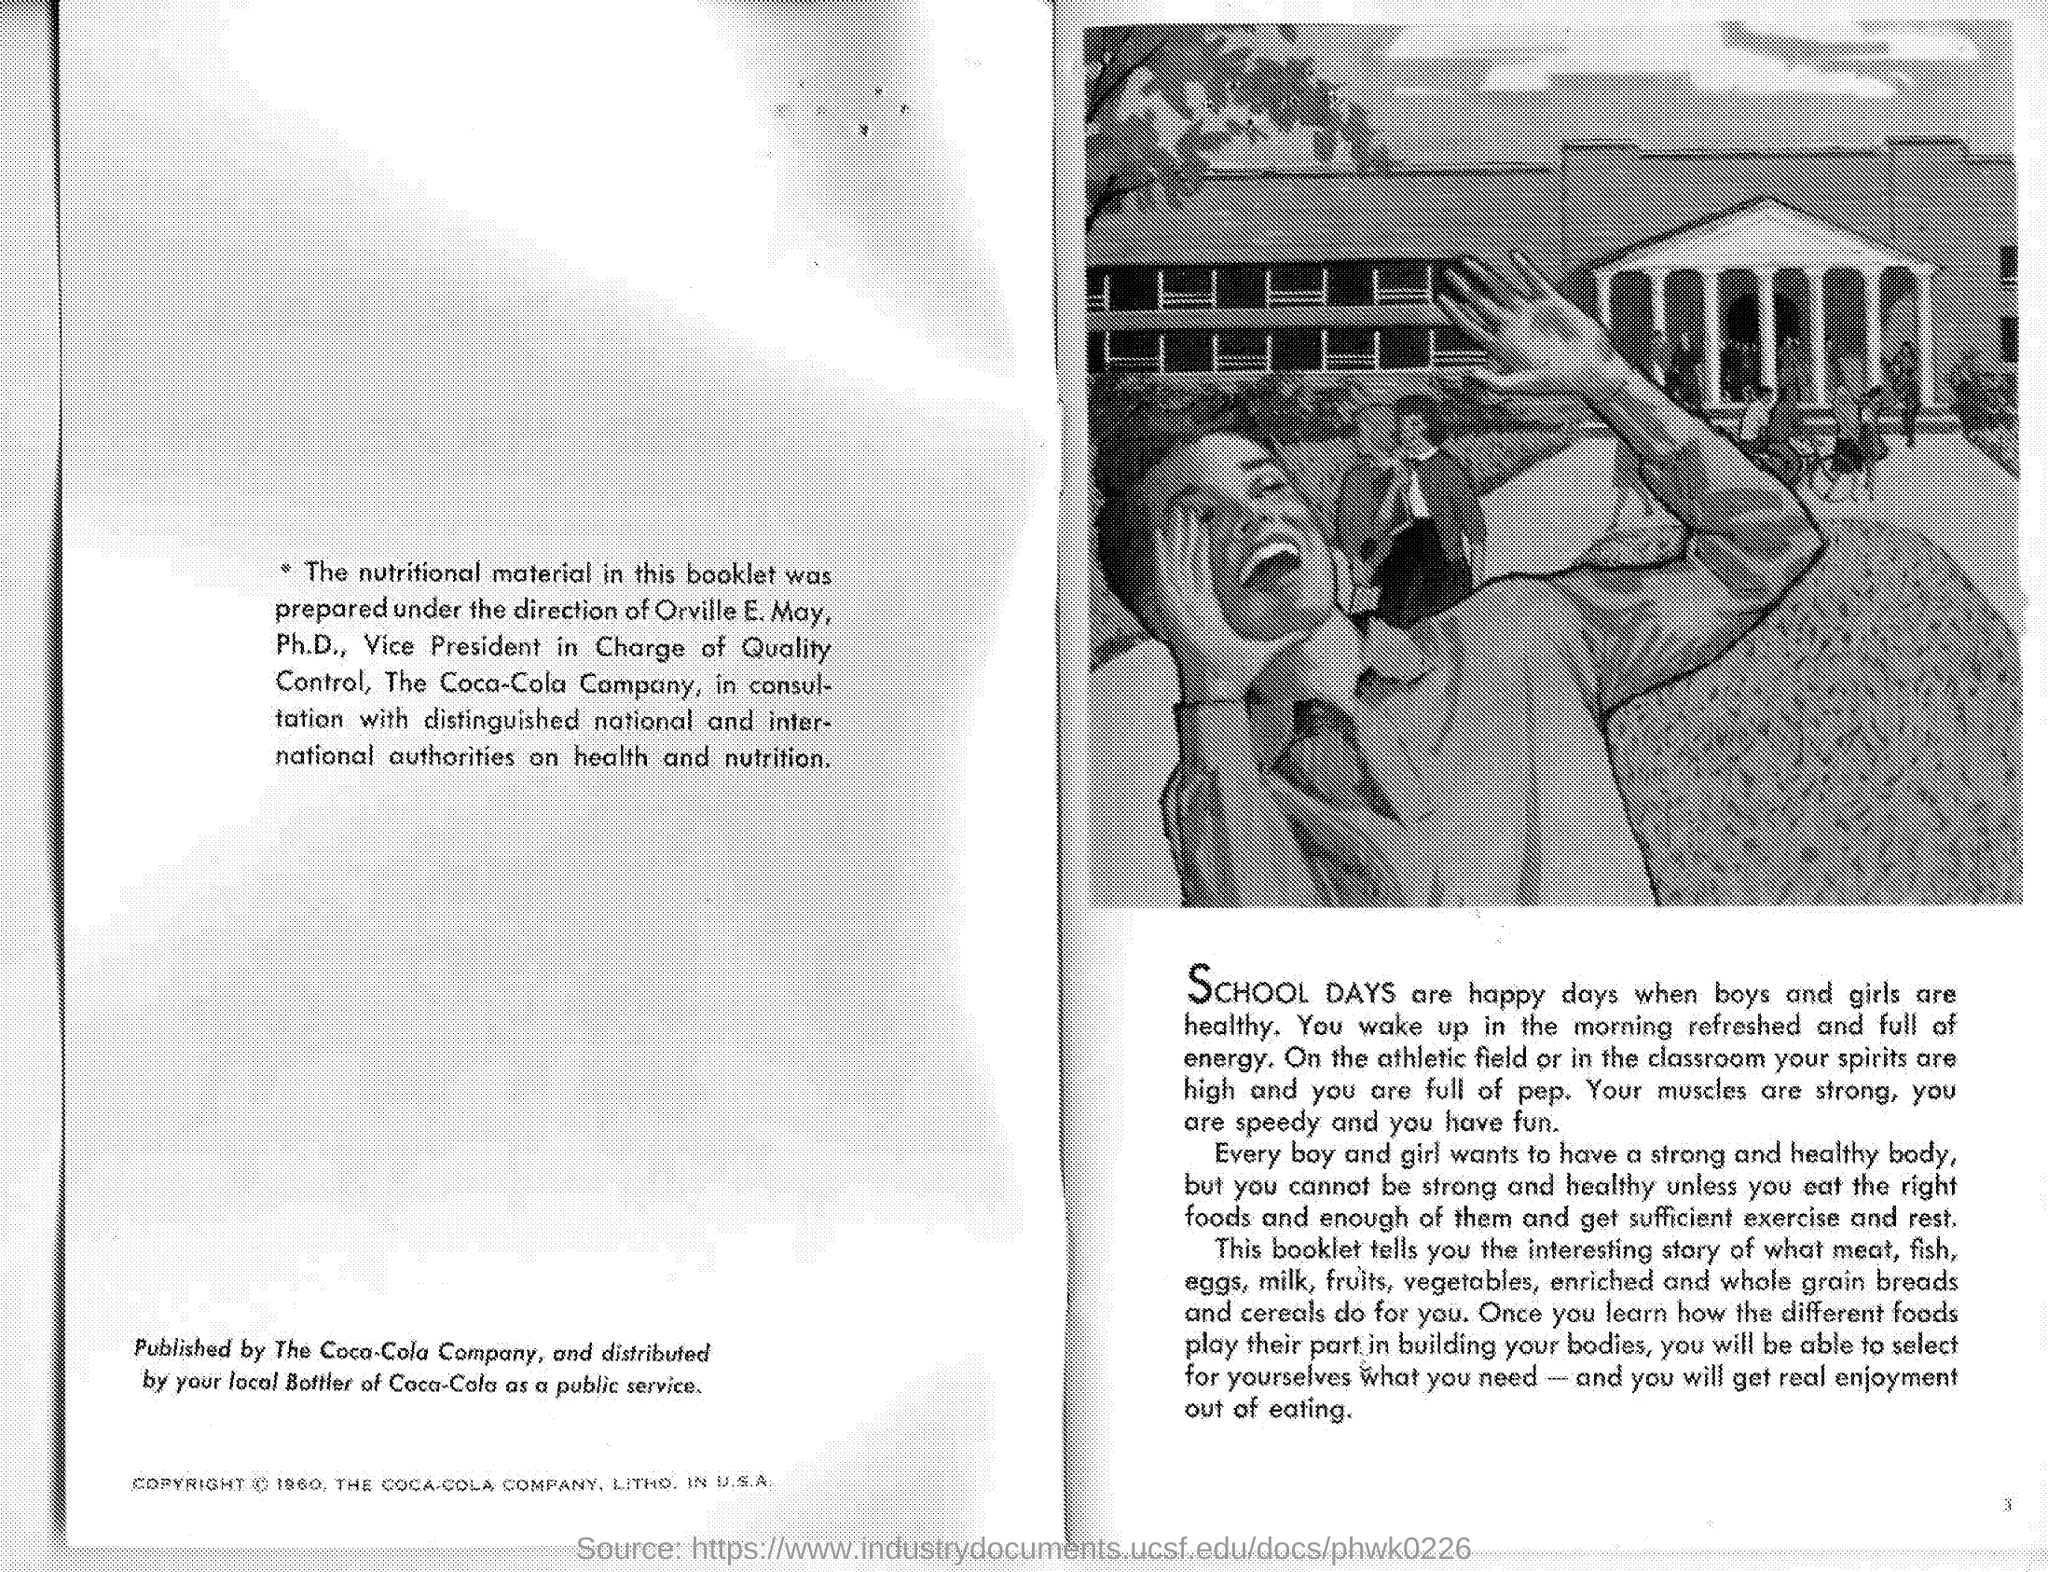Highlight a few significant elements in this photo. The nutritional material in this booklet was prepared under the direction of Orville E. May. He works for The Coca-Cola Company. 